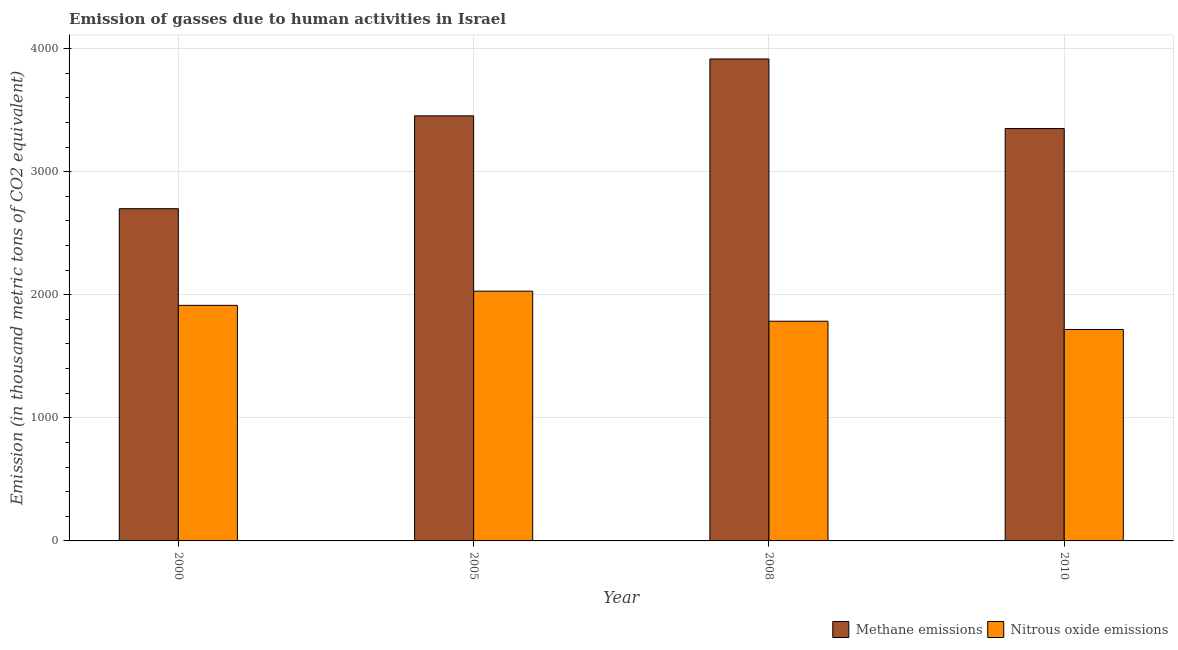How many bars are there on the 4th tick from the right?
Give a very brief answer. 2. What is the label of the 3rd group of bars from the left?
Your response must be concise. 2008. In how many cases, is the number of bars for a given year not equal to the number of legend labels?
Offer a terse response. 0. What is the amount of nitrous oxide emissions in 2010?
Your answer should be compact. 1717.7. Across all years, what is the maximum amount of nitrous oxide emissions?
Provide a short and direct response. 2029. Across all years, what is the minimum amount of methane emissions?
Make the answer very short. 2698.8. In which year was the amount of nitrous oxide emissions minimum?
Provide a short and direct response. 2010. What is the total amount of nitrous oxide emissions in the graph?
Offer a very short reply. 7445.2. What is the difference between the amount of methane emissions in 2005 and that in 2010?
Provide a short and direct response. 103.2. What is the difference between the amount of methane emissions in 2000 and the amount of nitrous oxide emissions in 2005?
Offer a terse response. -754.5. What is the average amount of methane emissions per year?
Ensure brevity in your answer.  3354.38. In the year 2010, what is the difference between the amount of methane emissions and amount of nitrous oxide emissions?
Your answer should be very brief. 0. In how many years, is the amount of methane emissions greater than 1800 thousand metric tons?
Provide a succinct answer. 4. What is the ratio of the amount of methane emissions in 2000 to that in 2010?
Give a very brief answer. 0.81. What is the difference between the highest and the second highest amount of methane emissions?
Give a very brief answer. 462. What is the difference between the highest and the lowest amount of nitrous oxide emissions?
Keep it short and to the point. 311.3. What does the 2nd bar from the left in 2010 represents?
Make the answer very short. Nitrous oxide emissions. What does the 2nd bar from the right in 2008 represents?
Ensure brevity in your answer.  Methane emissions. How many bars are there?
Offer a terse response. 8. Are all the bars in the graph horizontal?
Your answer should be very brief. No. Are the values on the major ticks of Y-axis written in scientific E-notation?
Your answer should be compact. No. Where does the legend appear in the graph?
Your response must be concise. Bottom right. What is the title of the graph?
Keep it short and to the point. Emission of gasses due to human activities in Israel. What is the label or title of the X-axis?
Your answer should be compact. Year. What is the label or title of the Y-axis?
Give a very brief answer. Emission (in thousand metric tons of CO2 equivalent). What is the Emission (in thousand metric tons of CO2 equivalent) in Methane emissions in 2000?
Keep it short and to the point. 2698.8. What is the Emission (in thousand metric tons of CO2 equivalent) of Nitrous oxide emissions in 2000?
Offer a very short reply. 1913.7. What is the Emission (in thousand metric tons of CO2 equivalent) of Methane emissions in 2005?
Provide a short and direct response. 3453.3. What is the Emission (in thousand metric tons of CO2 equivalent) in Nitrous oxide emissions in 2005?
Offer a terse response. 2029. What is the Emission (in thousand metric tons of CO2 equivalent) of Methane emissions in 2008?
Keep it short and to the point. 3915.3. What is the Emission (in thousand metric tons of CO2 equivalent) in Nitrous oxide emissions in 2008?
Ensure brevity in your answer.  1784.8. What is the Emission (in thousand metric tons of CO2 equivalent) in Methane emissions in 2010?
Offer a terse response. 3350.1. What is the Emission (in thousand metric tons of CO2 equivalent) of Nitrous oxide emissions in 2010?
Provide a short and direct response. 1717.7. Across all years, what is the maximum Emission (in thousand metric tons of CO2 equivalent) in Methane emissions?
Make the answer very short. 3915.3. Across all years, what is the maximum Emission (in thousand metric tons of CO2 equivalent) of Nitrous oxide emissions?
Your answer should be compact. 2029. Across all years, what is the minimum Emission (in thousand metric tons of CO2 equivalent) in Methane emissions?
Keep it short and to the point. 2698.8. Across all years, what is the minimum Emission (in thousand metric tons of CO2 equivalent) in Nitrous oxide emissions?
Give a very brief answer. 1717.7. What is the total Emission (in thousand metric tons of CO2 equivalent) of Methane emissions in the graph?
Offer a very short reply. 1.34e+04. What is the total Emission (in thousand metric tons of CO2 equivalent) of Nitrous oxide emissions in the graph?
Give a very brief answer. 7445.2. What is the difference between the Emission (in thousand metric tons of CO2 equivalent) of Methane emissions in 2000 and that in 2005?
Ensure brevity in your answer.  -754.5. What is the difference between the Emission (in thousand metric tons of CO2 equivalent) of Nitrous oxide emissions in 2000 and that in 2005?
Give a very brief answer. -115.3. What is the difference between the Emission (in thousand metric tons of CO2 equivalent) of Methane emissions in 2000 and that in 2008?
Your response must be concise. -1216.5. What is the difference between the Emission (in thousand metric tons of CO2 equivalent) of Nitrous oxide emissions in 2000 and that in 2008?
Offer a very short reply. 128.9. What is the difference between the Emission (in thousand metric tons of CO2 equivalent) of Methane emissions in 2000 and that in 2010?
Provide a short and direct response. -651.3. What is the difference between the Emission (in thousand metric tons of CO2 equivalent) of Nitrous oxide emissions in 2000 and that in 2010?
Give a very brief answer. 196. What is the difference between the Emission (in thousand metric tons of CO2 equivalent) of Methane emissions in 2005 and that in 2008?
Provide a succinct answer. -462. What is the difference between the Emission (in thousand metric tons of CO2 equivalent) of Nitrous oxide emissions in 2005 and that in 2008?
Offer a terse response. 244.2. What is the difference between the Emission (in thousand metric tons of CO2 equivalent) in Methane emissions in 2005 and that in 2010?
Provide a succinct answer. 103.2. What is the difference between the Emission (in thousand metric tons of CO2 equivalent) in Nitrous oxide emissions in 2005 and that in 2010?
Your answer should be compact. 311.3. What is the difference between the Emission (in thousand metric tons of CO2 equivalent) in Methane emissions in 2008 and that in 2010?
Provide a short and direct response. 565.2. What is the difference between the Emission (in thousand metric tons of CO2 equivalent) in Nitrous oxide emissions in 2008 and that in 2010?
Make the answer very short. 67.1. What is the difference between the Emission (in thousand metric tons of CO2 equivalent) in Methane emissions in 2000 and the Emission (in thousand metric tons of CO2 equivalent) in Nitrous oxide emissions in 2005?
Your response must be concise. 669.8. What is the difference between the Emission (in thousand metric tons of CO2 equivalent) in Methane emissions in 2000 and the Emission (in thousand metric tons of CO2 equivalent) in Nitrous oxide emissions in 2008?
Your answer should be very brief. 914. What is the difference between the Emission (in thousand metric tons of CO2 equivalent) in Methane emissions in 2000 and the Emission (in thousand metric tons of CO2 equivalent) in Nitrous oxide emissions in 2010?
Offer a very short reply. 981.1. What is the difference between the Emission (in thousand metric tons of CO2 equivalent) of Methane emissions in 2005 and the Emission (in thousand metric tons of CO2 equivalent) of Nitrous oxide emissions in 2008?
Give a very brief answer. 1668.5. What is the difference between the Emission (in thousand metric tons of CO2 equivalent) in Methane emissions in 2005 and the Emission (in thousand metric tons of CO2 equivalent) in Nitrous oxide emissions in 2010?
Your answer should be compact. 1735.6. What is the difference between the Emission (in thousand metric tons of CO2 equivalent) of Methane emissions in 2008 and the Emission (in thousand metric tons of CO2 equivalent) of Nitrous oxide emissions in 2010?
Your response must be concise. 2197.6. What is the average Emission (in thousand metric tons of CO2 equivalent) of Methane emissions per year?
Keep it short and to the point. 3354.38. What is the average Emission (in thousand metric tons of CO2 equivalent) in Nitrous oxide emissions per year?
Your answer should be compact. 1861.3. In the year 2000, what is the difference between the Emission (in thousand metric tons of CO2 equivalent) in Methane emissions and Emission (in thousand metric tons of CO2 equivalent) in Nitrous oxide emissions?
Offer a terse response. 785.1. In the year 2005, what is the difference between the Emission (in thousand metric tons of CO2 equivalent) of Methane emissions and Emission (in thousand metric tons of CO2 equivalent) of Nitrous oxide emissions?
Provide a succinct answer. 1424.3. In the year 2008, what is the difference between the Emission (in thousand metric tons of CO2 equivalent) of Methane emissions and Emission (in thousand metric tons of CO2 equivalent) of Nitrous oxide emissions?
Provide a short and direct response. 2130.5. In the year 2010, what is the difference between the Emission (in thousand metric tons of CO2 equivalent) of Methane emissions and Emission (in thousand metric tons of CO2 equivalent) of Nitrous oxide emissions?
Ensure brevity in your answer.  1632.4. What is the ratio of the Emission (in thousand metric tons of CO2 equivalent) in Methane emissions in 2000 to that in 2005?
Offer a very short reply. 0.78. What is the ratio of the Emission (in thousand metric tons of CO2 equivalent) in Nitrous oxide emissions in 2000 to that in 2005?
Keep it short and to the point. 0.94. What is the ratio of the Emission (in thousand metric tons of CO2 equivalent) of Methane emissions in 2000 to that in 2008?
Provide a succinct answer. 0.69. What is the ratio of the Emission (in thousand metric tons of CO2 equivalent) of Nitrous oxide emissions in 2000 to that in 2008?
Offer a terse response. 1.07. What is the ratio of the Emission (in thousand metric tons of CO2 equivalent) in Methane emissions in 2000 to that in 2010?
Provide a short and direct response. 0.81. What is the ratio of the Emission (in thousand metric tons of CO2 equivalent) in Nitrous oxide emissions in 2000 to that in 2010?
Offer a terse response. 1.11. What is the ratio of the Emission (in thousand metric tons of CO2 equivalent) of Methane emissions in 2005 to that in 2008?
Make the answer very short. 0.88. What is the ratio of the Emission (in thousand metric tons of CO2 equivalent) of Nitrous oxide emissions in 2005 to that in 2008?
Give a very brief answer. 1.14. What is the ratio of the Emission (in thousand metric tons of CO2 equivalent) of Methane emissions in 2005 to that in 2010?
Make the answer very short. 1.03. What is the ratio of the Emission (in thousand metric tons of CO2 equivalent) in Nitrous oxide emissions in 2005 to that in 2010?
Offer a very short reply. 1.18. What is the ratio of the Emission (in thousand metric tons of CO2 equivalent) of Methane emissions in 2008 to that in 2010?
Your answer should be very brief. 1.17. What is the ratio of the Emission (in thousand metric tons of CO2 equivalent) of Nitrous oxide emissions in 2008 to that in 2010?
Offer a very short reply. 1.04. What is the difference between the highest and the second highest Emission (in thousand metric tons of CO2 equivalent) of Methane emissions?
Provide a short and direct response. 462. What is the difference between the highest and the second highest Emission (in thousand metric tons of CO2 equivalent) in Nitrous oxide emissions?
Keep it short and to the point. 115.3. What is the difference between the highest and the lowest Emission (in thousand metric tons of CO2 equivalent) of Methane emissions?
Your response must be concise. 1216.5. What is the difference between the highest and the lowest Emission (in thousand metric tons of CO2 equivalent) of Nitrous oxide emissions?
Provide a short and direct response. 311.3. 